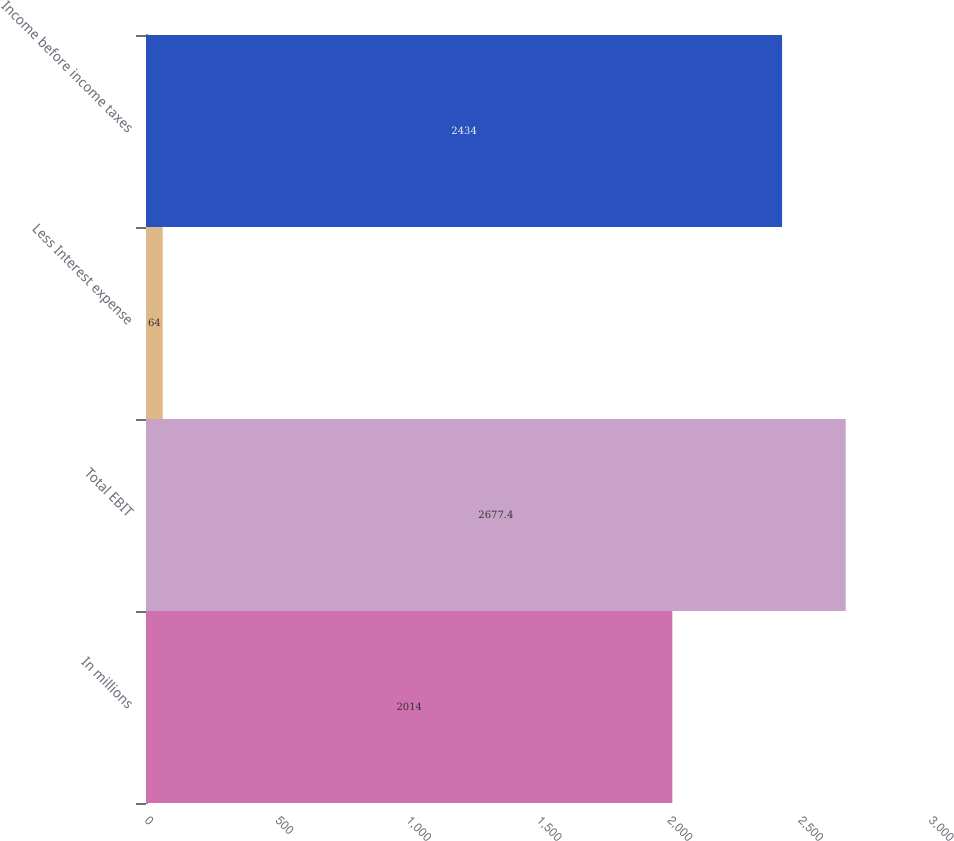Convert chart to OTSL. <chart><loc_0><loc_0><loc_500><loc_500><bar_chart><fcel>In millions<fcel>Total EBIT<fcel>Less Interest expense<fcel>Income before income taxes<nl><fcel>2014<fcel>2677.4<fcel>64<fcel>2434<nl></chart> 